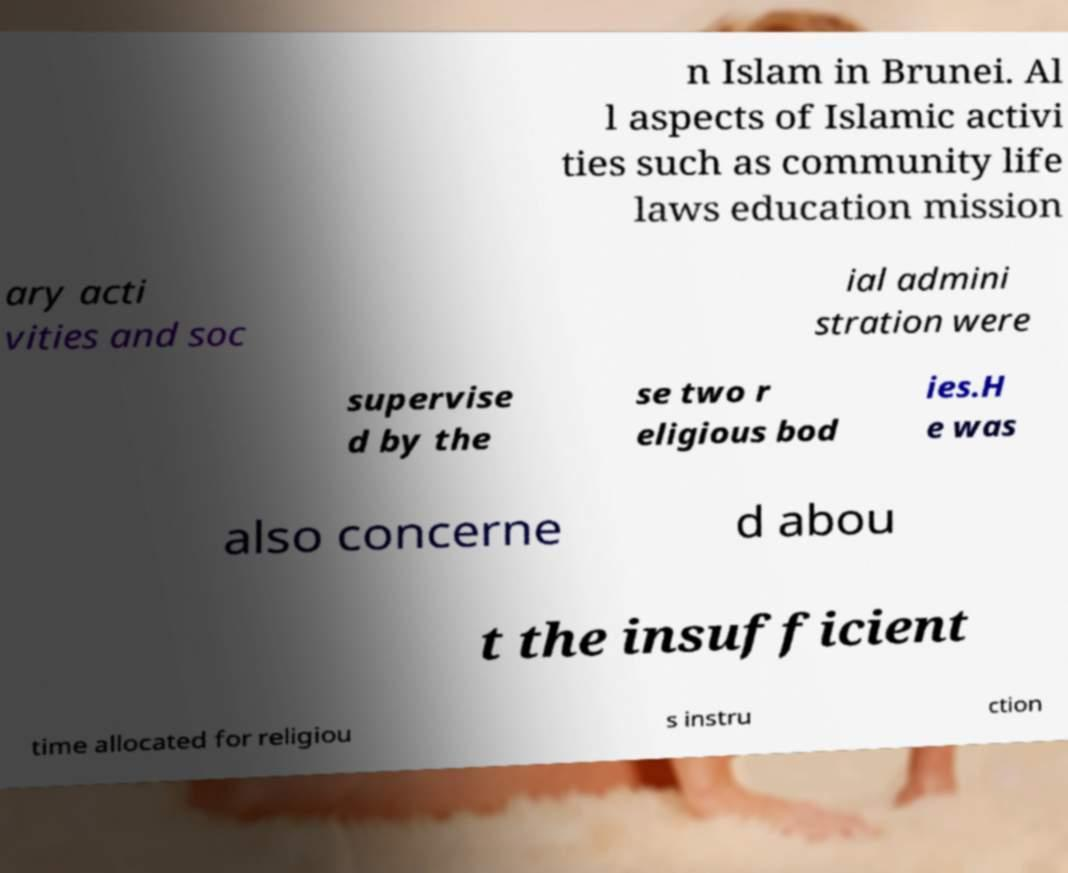Could you assist in decoding the text presented in this image and type it out clearly? n Islam in Brunei. Al l aspects of Islamic activi ties such as community life laws education mission ary acti vities and soc ial admini stration were supervise d by the se two r eligious bod ies.H e was also concerne d abou t the insufficient time allocated for religiou s instru ction 